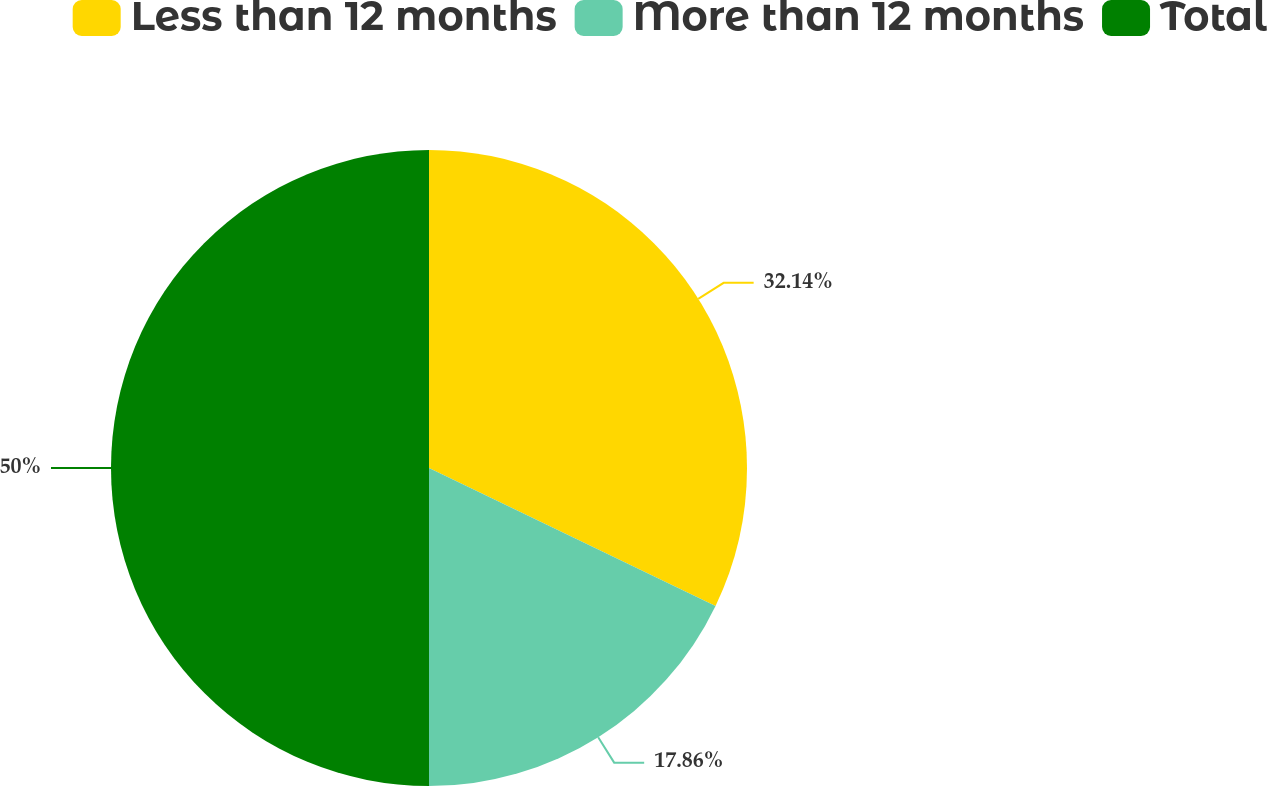<chart> <loc_0><loc_0><loc_500><loc_500><pie_chart><fcel>Less than 12 months<fcel>More than 12 months<fcel>Total<nl><fcel>32.14%<fcel>17.86%<fcel>50.0%<nl></chart> 